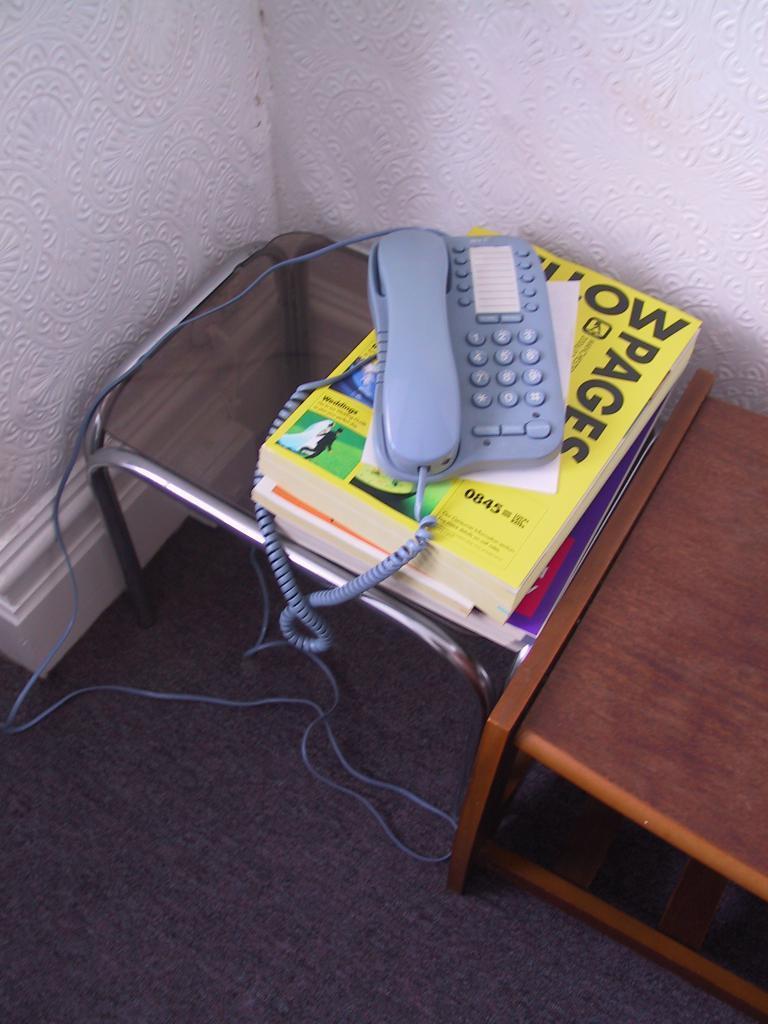Please provide a concise description of this image. In this image there is a landline phone on books on a table , and the back ground there is another table, wall, carpet. 